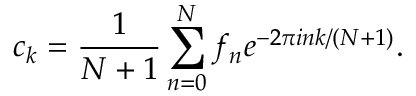Convert formula to latex. <formula><loc_0><loc_0><loc_500><loc_500>c _ { k } = \frac { 1 } { N + 1 } \sum _ { n = 0 } ^ { N } f _ { n } e ^ { - 2 \pi i n k / ( N + 1 ) } .</formula> 